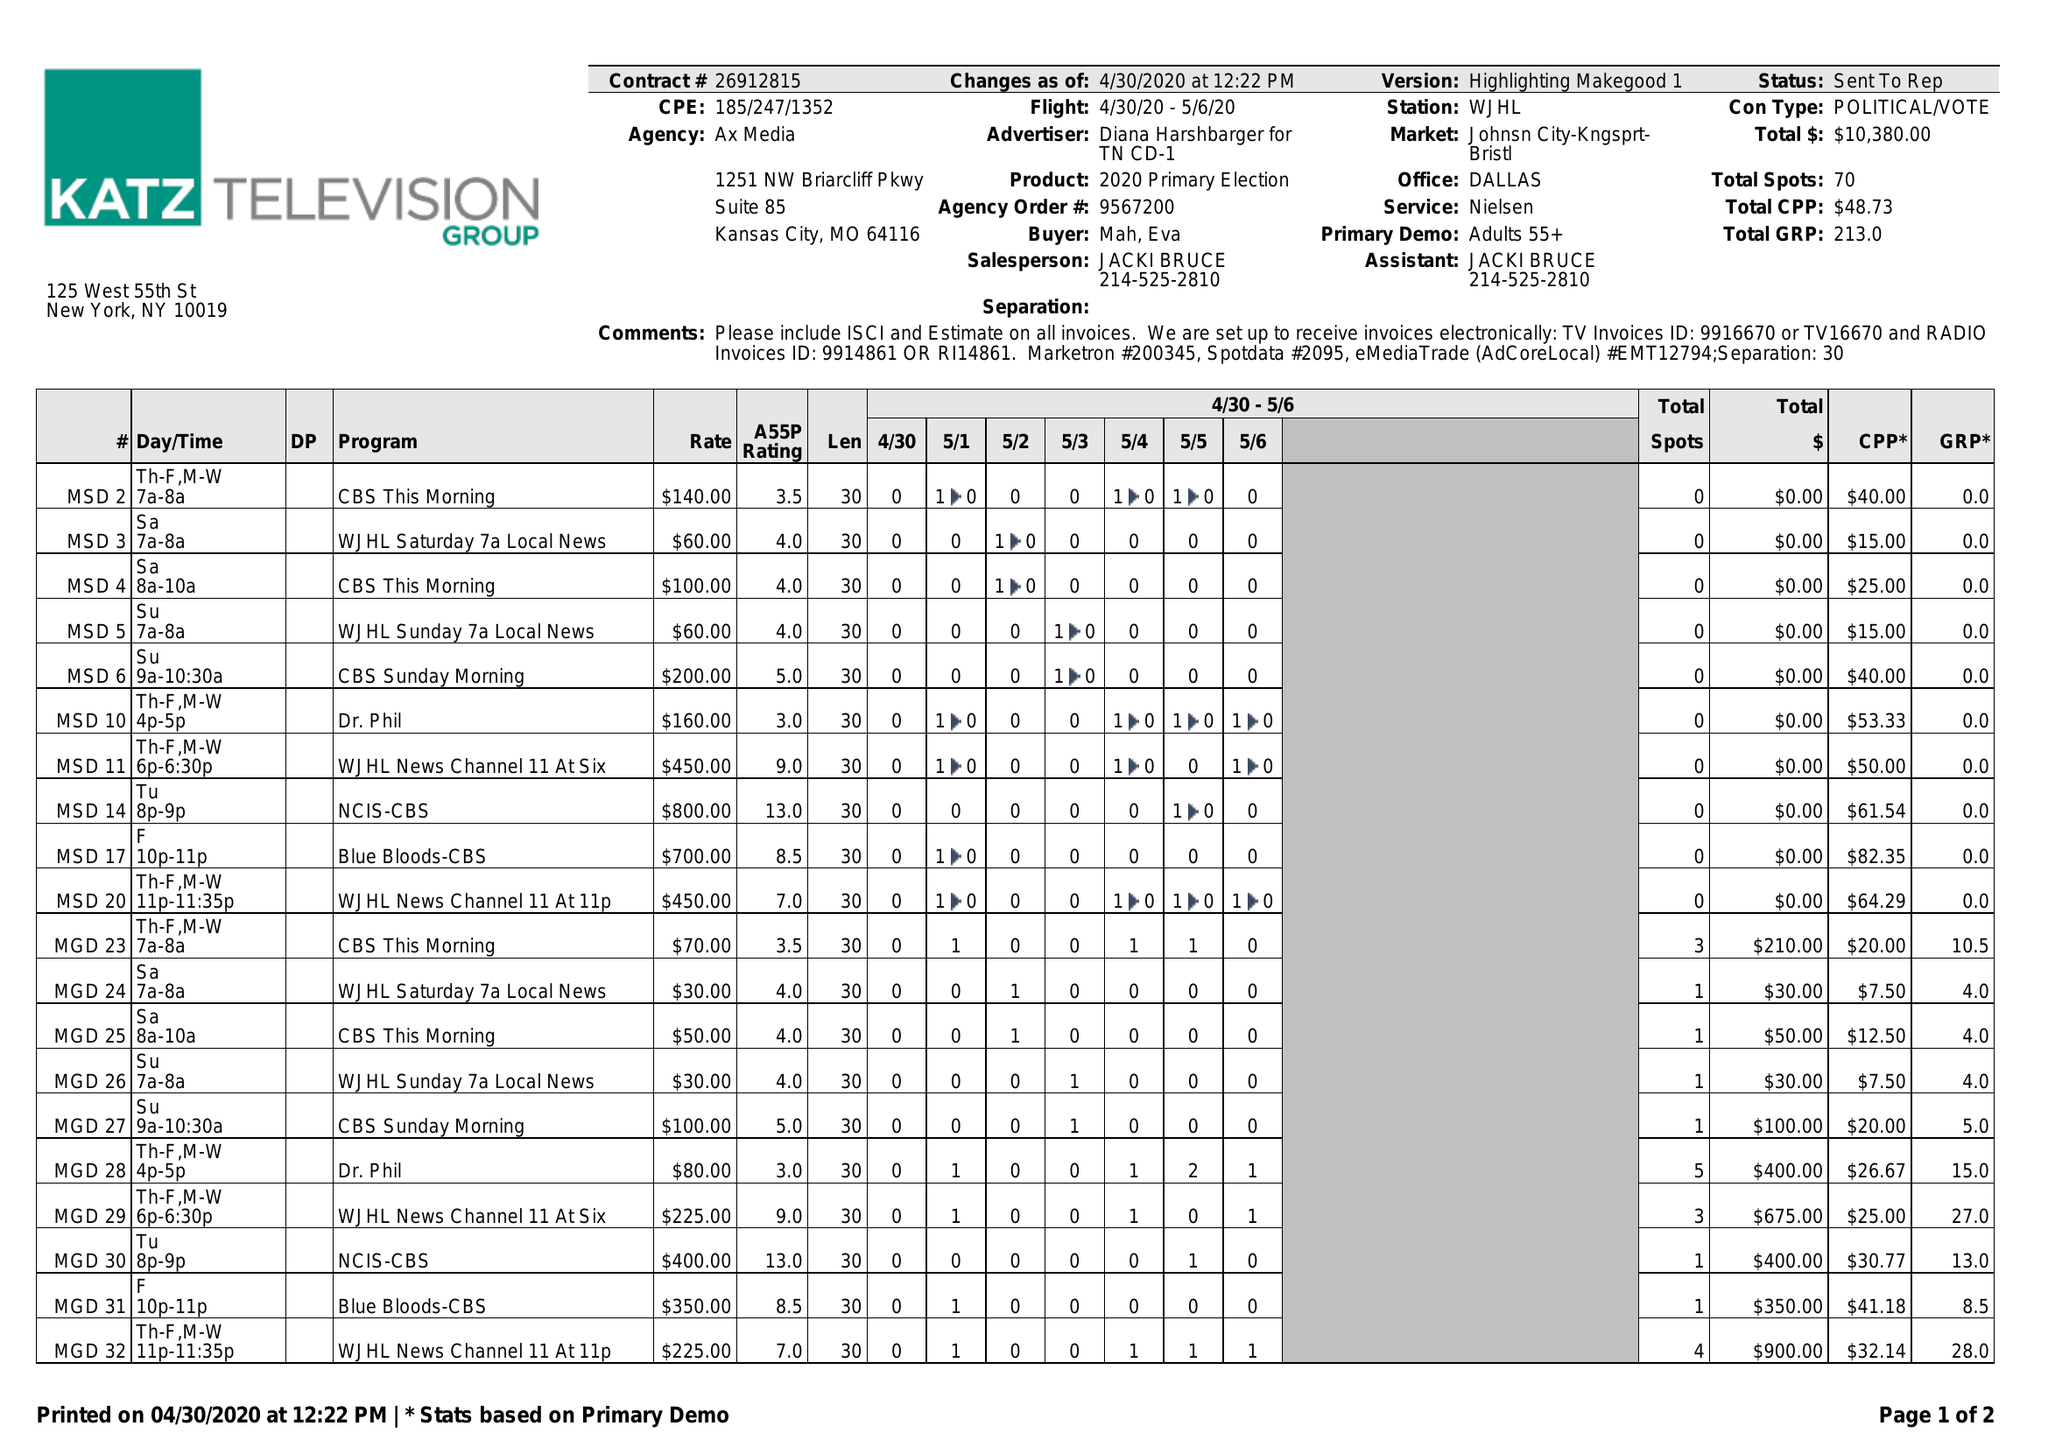What is the value for the flight_from?
Answer the question using a single word or phrase. 04/30/20 